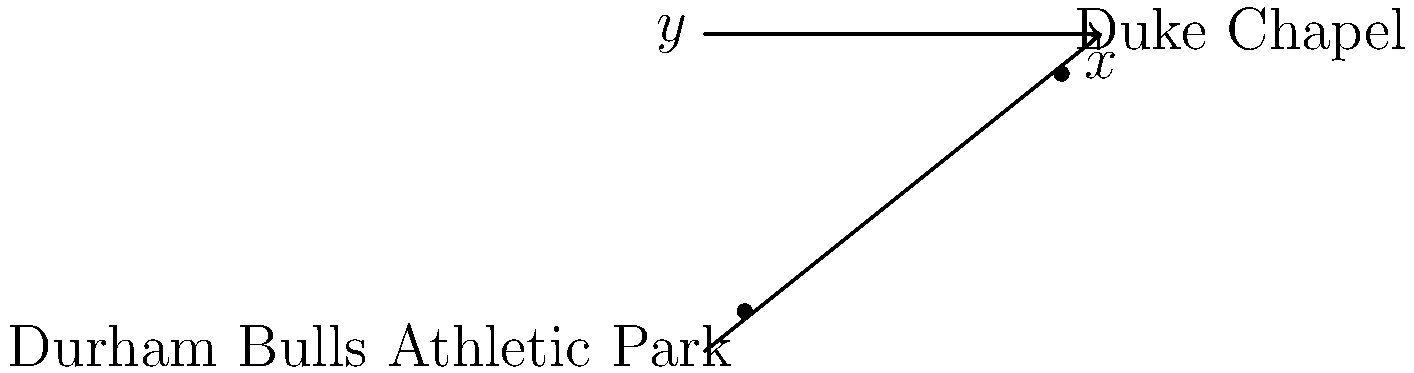As a local business owner in Durham, you're planning an event that involves both the Durham Bulls Athletic Park and Duke Chapel. On a coordinate grid where each unit represents 0.5 miles, the Durham Bulls Athletic Park is located at (0,0) and Duke Chapel is at (8,6). Using the distance formula, calculate the straight-line distance between these two landmarks to the nearest tenth of a mile. To solve this problem, we'll use the distance formula:

$$d = \sqrt{(x_2 - x_1)^2 + (y_2 - y_1)^2}$$

Where $(x_1, y_1)$ is the coordinate of the Durham Bulls Athletic Park (0,0) and $(x_2, y_2)$ is the coordinate of Duke Chapel (8,6).

Step 1: Plug the coordinates into the formula:
$$d = \sqrt{(8 - 0)^2 + (6 - 0)^2}$$

Step 2: Simplify inside the parentheses:
$$d = \sqrt{8^2 + 6^2}$$

Step 3: Calculate the squares:
$$d = \sqrt{64 + 36}$$

Step 4: Add under the square root:
$$d = \sqrt{100}$$

Step 5: Simplify:
$$d = 10$$

Step 6: Since each unit represents 0.5 miles, multiply the result by 0.5:
$$10 \times 0.5 = 5\text{ miles}$$

Therefore, the straight-line distance between Durham Bulls Athletic Park and Duke Chapel is 5 miles.
Answer: 5 miles 